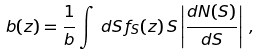Convert formula to latex. <formula><loc_0><loc_0><loc_500><loc_500>b ( z ) = \frac { 1 } { b } \int \, d S \, f _ { S } ( z ) \, S \left | \frac { d N ( S ) } { d S } \right | \, ,</formula> 